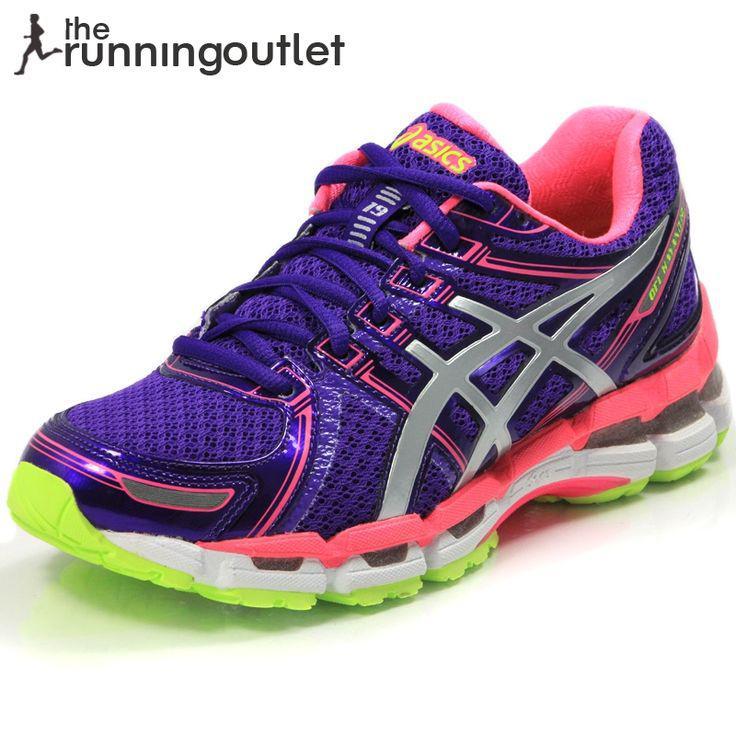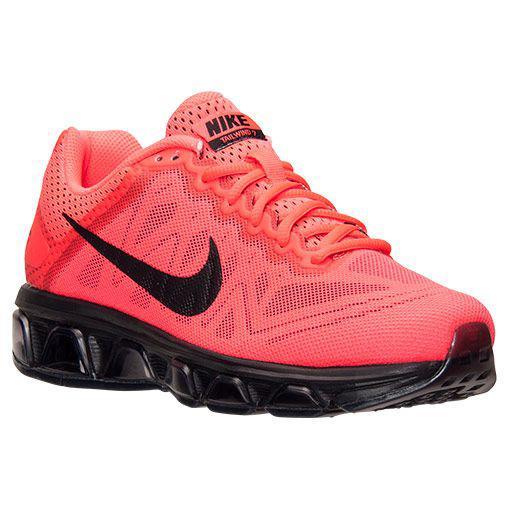The first image is the image on the left, the second image is the image on the right. For the images displayed, is the sentence "The shoe in the image on the right has orange laces." factually correct? Answer yes or no. Yes. 